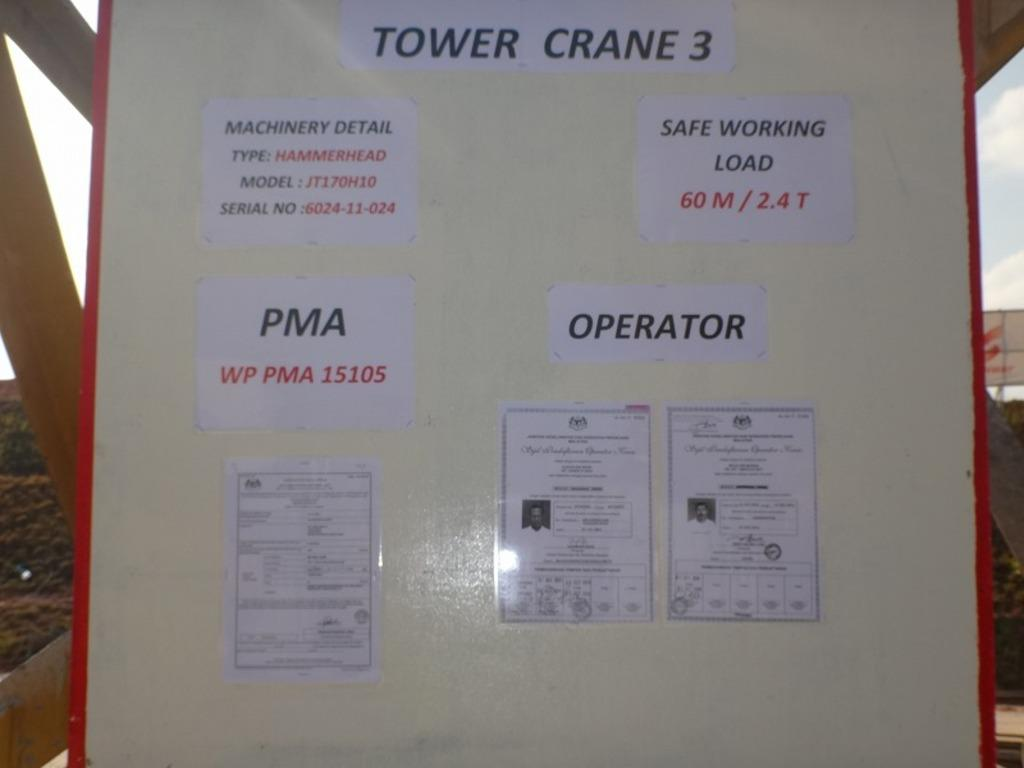<image>
Create a compact narrative representing the image presented. A poster has the text "TOWER CRANE 3" and "MACHINERY DETAIL, "SAFE WORKING LOAD," "PMA," and "OPERATOR." 